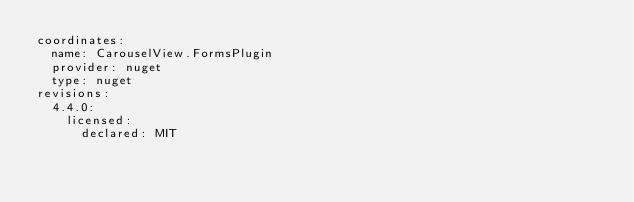Convert code to text. <code><loc_0><loc_0><loc_500><loc_500><_YAML_>coordinates:
  name: CarouselView.FormsPlugin
  provider: nuget
  type: nuget
revisions:
  4.4.0:
    licensed:
      declared: MIT
</code> 